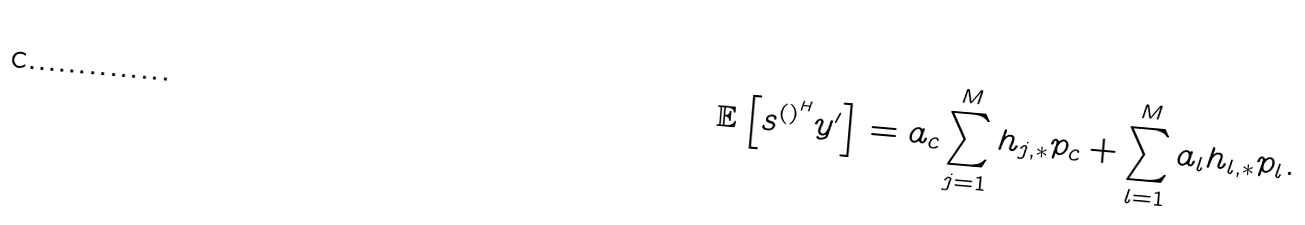Convert formula to latex. <formula><loc_0><loc_0><loc_500><loc_500>\mathbb { E } \left [ s ^ { \left ( \right ) ^ { H } } y ^ { \prime } \right ] = a _ { c } \sum _ { j = 1 } ^ { M } h _ { j , * } p _ { c } + \sum _ { l = 1 } ^ { M } a _ { l } h _ { l , * } p _ { l } .</formula> 